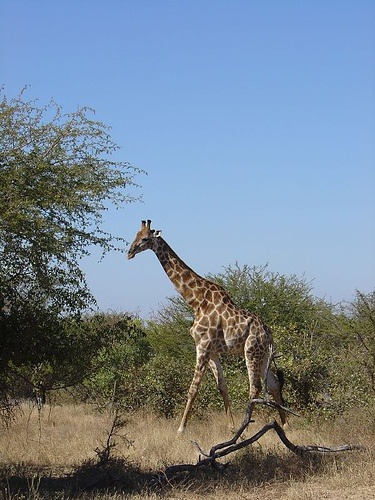Describe the objects in this image and their specific colors. I can see a giraffe in darkgray, black, gray, and maroon tones in this image. 